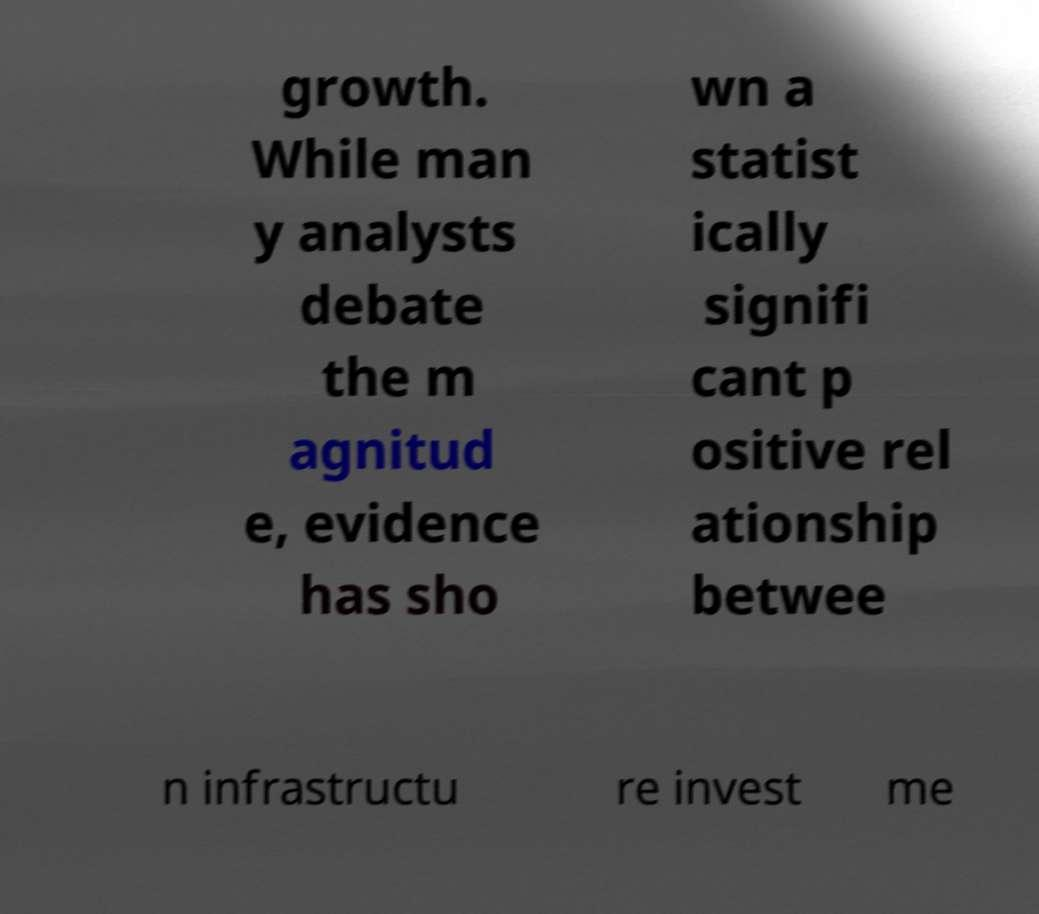Could you assist in decoding the text presented in this image and type it out clearly? growth. While man y analysts debate the m agnitud e, evidence has sho wn a statist ically signifi cant p ositive rel ationship betwee n infrastructu re invest me 